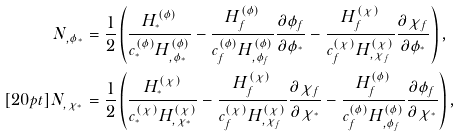<formula> <loc_0><loc_0><loc_500><loc_500>N _ { , \phi _ { ^ { * } } } & = \frac { 1 } { 2 } \left ( \frac { H ^ { ( \phi ) } _ { ^ { * } } } { c ^ { ( \phi ) } _ { ^ { * } } H ^ { ( \phi ) } _ { , \phi _ { ^ { * } } } } - \frac { H ^ { ( \phi ) } _ { f } } { c ^ { ( \phi ) } _ { f } H ^ { ( \phi ) } _ { , \phi _ { f } } } \frac { \partial \phi _ { f } } { \partial \phi _ { ^ { * } } } - \frac { H ^ { ( \chi ) } _ { f } } { c ^ { ( \chi ) } _ { f } H ^ { ( \chi ) } _ { , \chi _ { f } } } \frac { \partial \chi _ { f } } { \partial \phi _ { ^ { * } } } \right ) , \\ [ 2 0 p t ] N _ { , \chi _ { ^ { * } } } & = \frac { 1 } { 2 } \left ( \frac { H ^ { ( \chi ) } _ { ^ { * } } } { c ^ { ( \chi ) } _ { ^ { * } } H ^ { ( \chi ) } _ { , \chi _ { ^ { * } } } } - \frac { H ^ { ( \chi ) } _ { f } } { c ^ { ( \chi ) } _ { f } H ^ { ( \chi ) } _ { , \chi _ { f } } } \frac { \partial \chi _ { f } } { \partial \chi _ { ^ { * } } } - \frac { H ^ { ( \phi ) } _ { f } } { c ^ { ( \phi ) } _ { f } H ^ { ( \phi ) } _ { , \phi _ { f } } } \frac { \partial \phi _ { f } } { \partial \chi _ { ^ { * } } } \right ) ,</formula> 